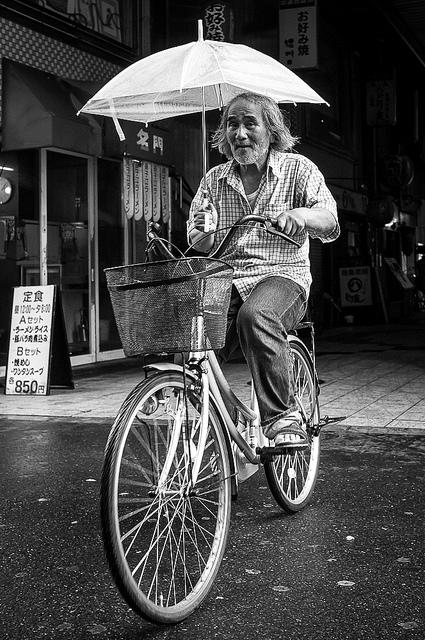Why is the woman holding an umbrella?
Quick response, please. Raining. Is he wearing a serious expression?
Keep it brief. No. What color is the photo?
Answer briefly. Black and white. What is the man holding?
Answer briefly. Umbrella. Is there a basket on her bike?
Quick response, please. Yes. What is the jug the man is carrying?
Answer briefly. Water. Is the woman steering the bike?
Short answer required. Yes. 